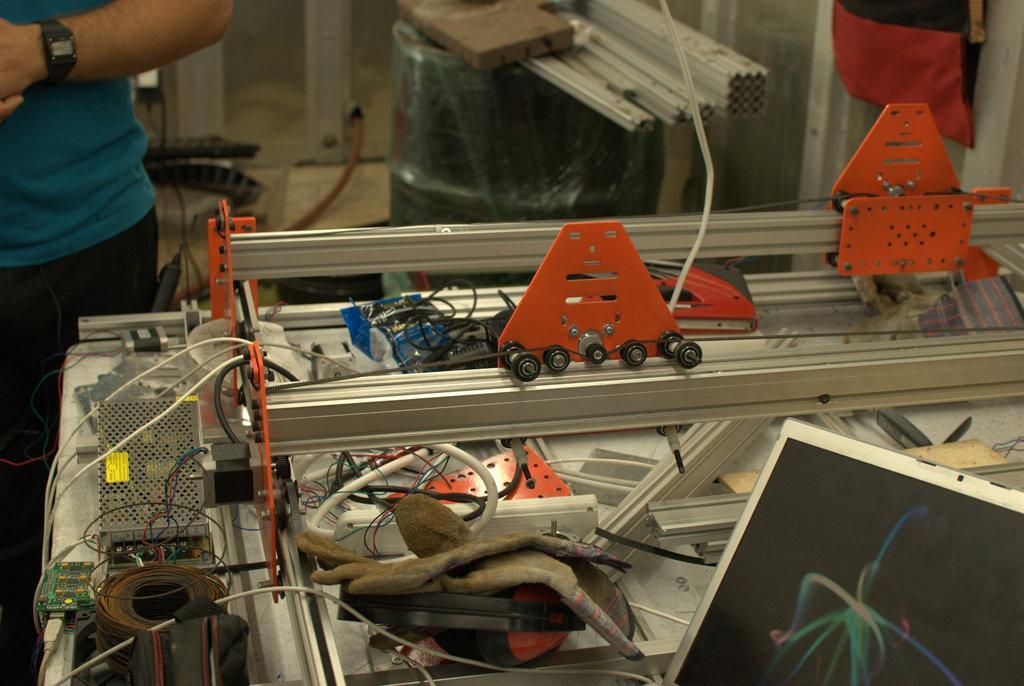Can you describe this image briefly? In this picture there is a person standing. In the foreground there is a machine and there is a laptop and there are gloves on the machine. At the back there are pipes and there is a wooden object on the drum and there is a bag hanging on the wall. At the bottom there is a pipe and there are objects. 